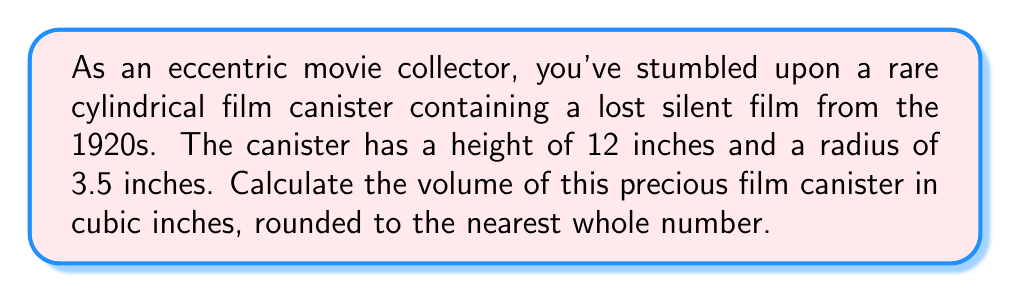Solve this math problem. To solve this problem, we'll use the formula for the volume of a cylinder:

$$V = \pi r^2 h$$

Where:
$V$ = volume
$r$ = radius
$h$ = height

Let's plug in the given values:

$r = 3.5$ inches
$h = 12$ inches

Now, let's calculate step-by-step:

1) Substitute the values into the formula:
   $$V = \pi (3.5)^2 (12)$$

2) Calculate the square of the radius:
   $$V = \pi (12.25) (12)$$

3) Multiply the values inside the parentheses:
   $$V = \pi (147)$$

4) Multiply by $\pi$ (use 3.14159 for π):
   $$V = 3.14159 \times 147 = 461.81383$$

5) Round to the nearest whole number:
   $$V \approx 462$$

Therefore, the volume of the cylindrical film canister is approximately 462 cubic inches.
Answer: 462 cubic inches 